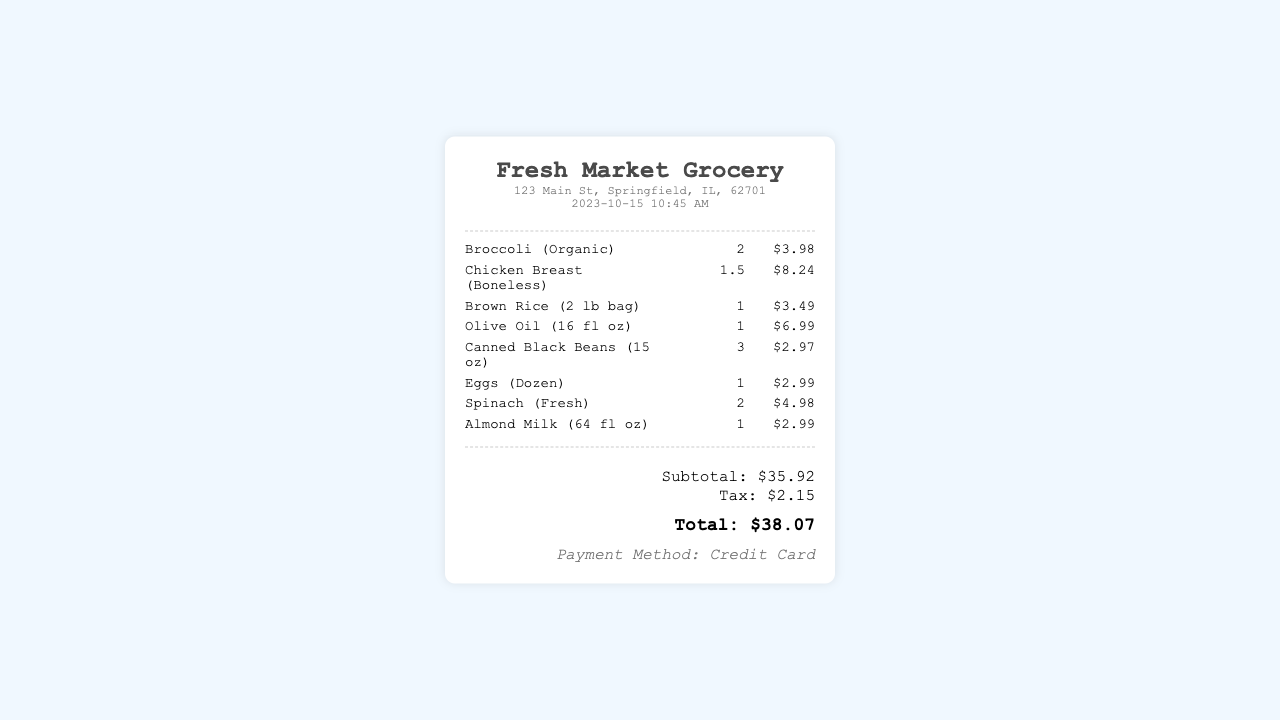What is the store name? The store name is prominently displayed at the top of the receipt.
Answer: Fresh Market Grocery What is the total cost of the items? The total cost is indicated at the bottom of the receipt in the summary section.
Answer: $38.07 How many cans of black beans were purchased? The quantity for canned black beans is listed with the item details in the items section.
Answer: 3 What is the price of chicken breast? The price of chicken breast can be found next to its description in the items section.
Answer: $8.24 What is the subtotal before tax? The subtotal before tax is shown in the summary section of the receipt.
Answer: $35.92 What method was used for payment? The payment method is specified at the bottom of the receipt.
Answer: Credit Card How many items were purchased in total? To determine the items, sum the quantities listed in the items section.
Answer: 10 What date was the receipt issued? The date can be found next to the store address in the header.
Answer: 2023-10-15 What is the price of olive oil? The price is mentioned next to the description of olive oil in the receipt.
Answer: $6.99 What is the tax amount applied? The tax amount is displayed in the summary section of the receipt.
Answer: $2.15 